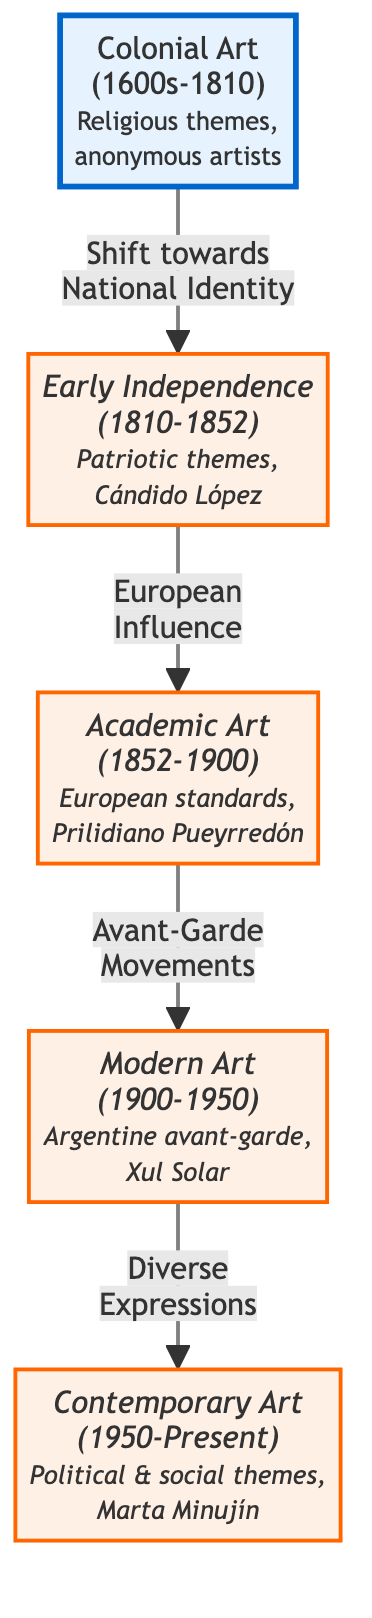What is the time period of Colonial Art? The diagram specifies that Colonial Art spans the years from 1600s to 1810. This is explicitly stated in the node for Colonial Art, which lists the time period prominently.
Answer: 1600s-1810 Which artist is associated with Early Independence? The Early Independence node mentions Cándido López as an artist associated with that period. This is information provided directly within that specific node.
Answer: Cándido López How many major periods of art are listed in the diagram? By counting the distinct nodes labeled as periods (Colonial Art, Early Independence, Academic Art, Modern Art, Contemporary Art), we identify that there are five major periods outlined in the diagram.
Answer: 5 What transition occurs between Academic Art and Modern Art? The diagram indicates that the transition from Academic Art to Modern Art is characterized by "Avant-Garde Movements." This phrase highlights the shift in artistic approach noted in that transition.
Answer: Avant-Garde Movements Which art period is defined by political and social themes? The node for Contemporary Art describes it as featuring political and social themes. This is a defining characteristic listed within that period's description in the diagram.
Answer: Contemporary Art What was a prominent influence during the Early Independence period? The diagram notes that the Early Independence period was influenced by European standards. This information connects the transition and highlights how European art impacts the evolution of Argentine art.
Answer: European Influence Which artist is mentioned in connection with Modern Art? Xul Solar is explicitly named in the Modern Art node as a significant artist from that period. This is a straightforward detail directly presented in the node itself.
Answer: Xul Solar What shift does Colonial Art undergo? The diagram states that Colonial Art experiences a shift towards National Identity, which is portrayed as the transition leading to the Early Independence period. This phrase summarizes the change recorded in the diagram.
Answer: Shift towards National Identity What significant feature is attributed to Contemporary Art in the diagram? The diagram emphasizes that Contemporary Art encompasses diverse expressions, which is highlighted as a significant aspect of that period in the visual flowchart.
Answer: Diverse Expressions 